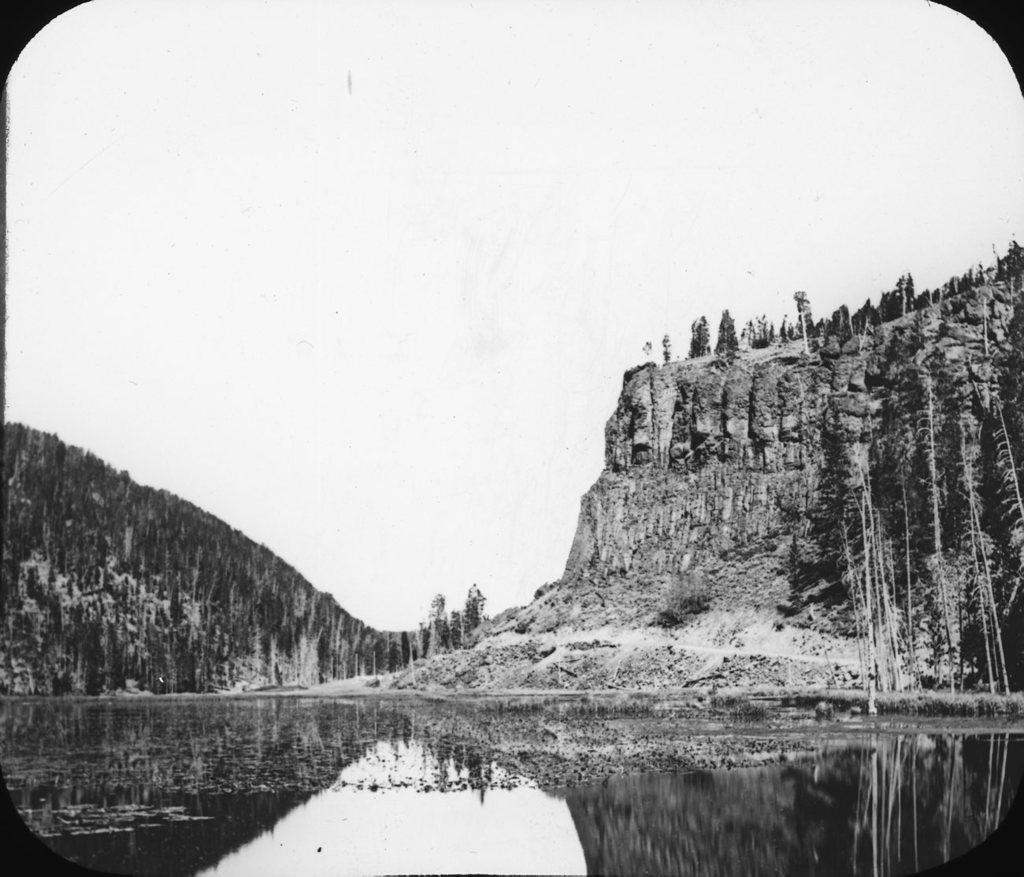How would you summarize this image in a sentence or two? This is a black and white image. At the bottom of the image I can see the water. In the background there are some hills. At the top I can see the sky. 